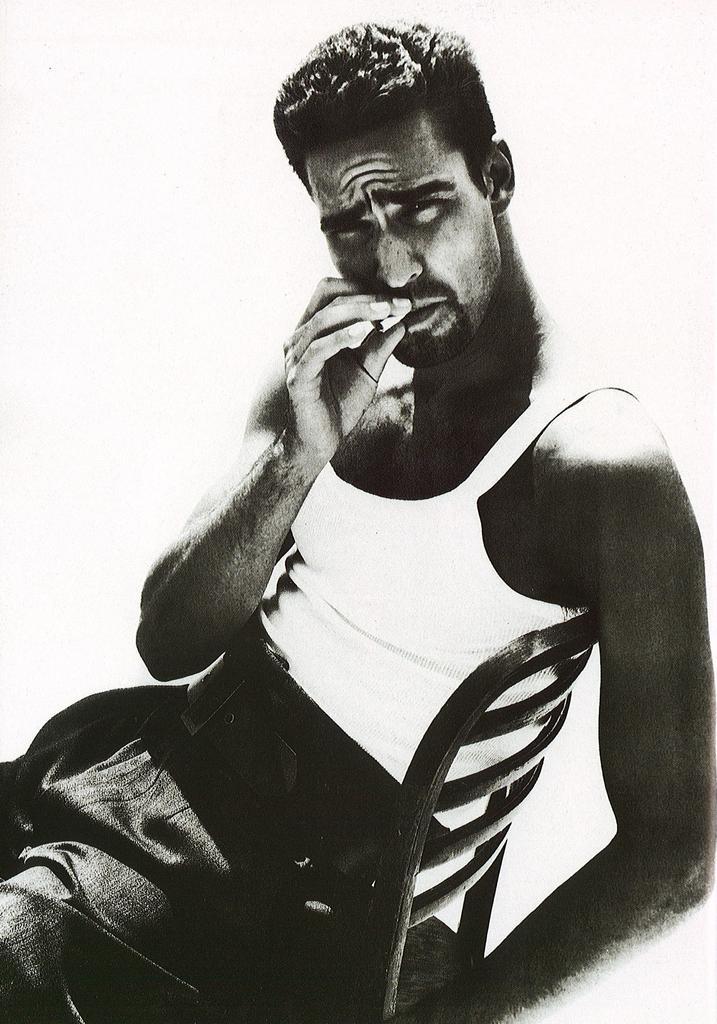How would you summarize this image in a sentence or two? In this image we can see a black and white picture of a person sitting on a chair holding an object in his hand. 